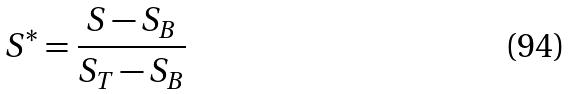Convert formula to latex. <formula><loc_0><loc_0><loc_500><loc_500>S ^ { * } = \frac { S - S _ { B } } { S _ { T } - S _ { B } }</formula> 